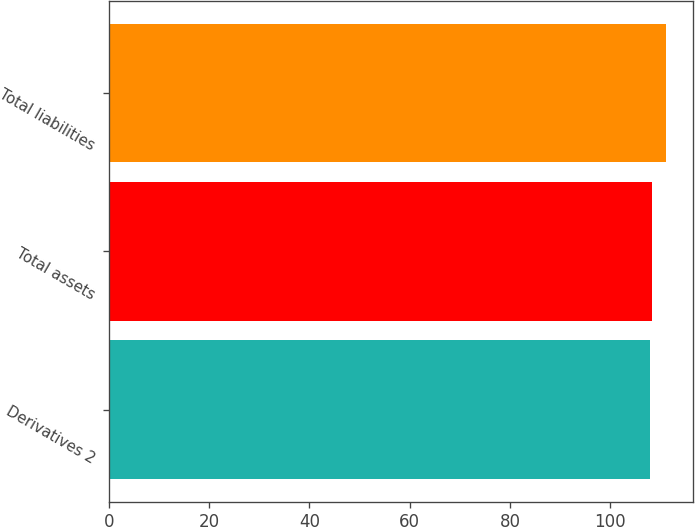Convert chart. <chart><loc_0><loc_0><loc_500><loc_500><bar_chart><fcel>Derivatives 2<fcel>Total assets<fcel>Total liabilities<nl><fcel>108<fcel>108.3<fcel>111<nl></chart> 